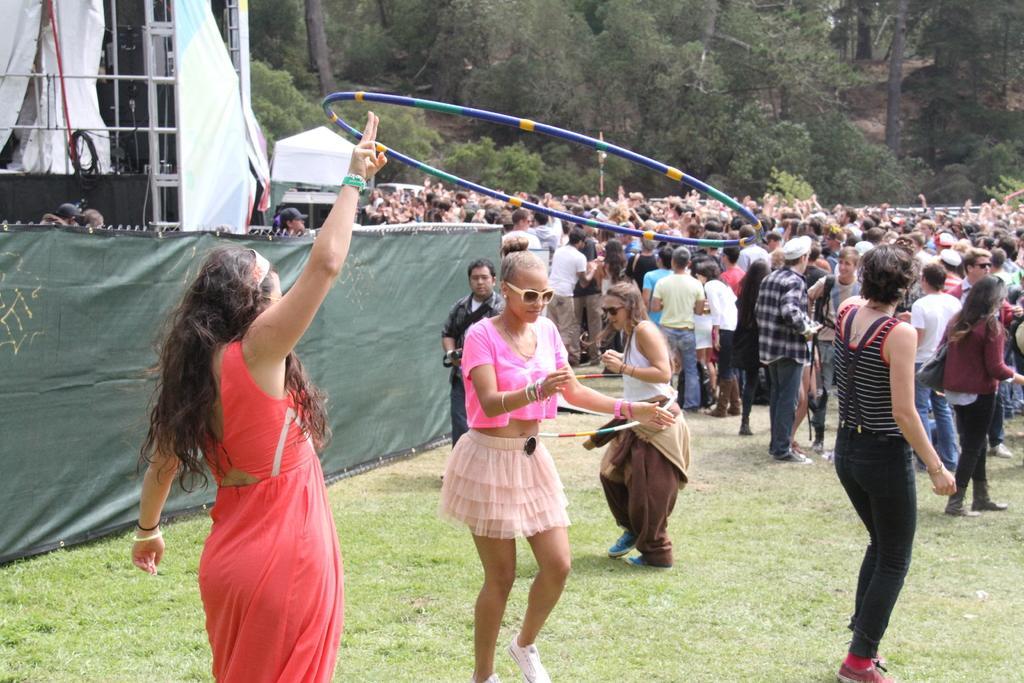Describe this image in one or two sentences. In this image I can see group of people standing. In front the person is wearing red color dress and holding the ring and I can see few clothes in white color, background the trees are in green color. 